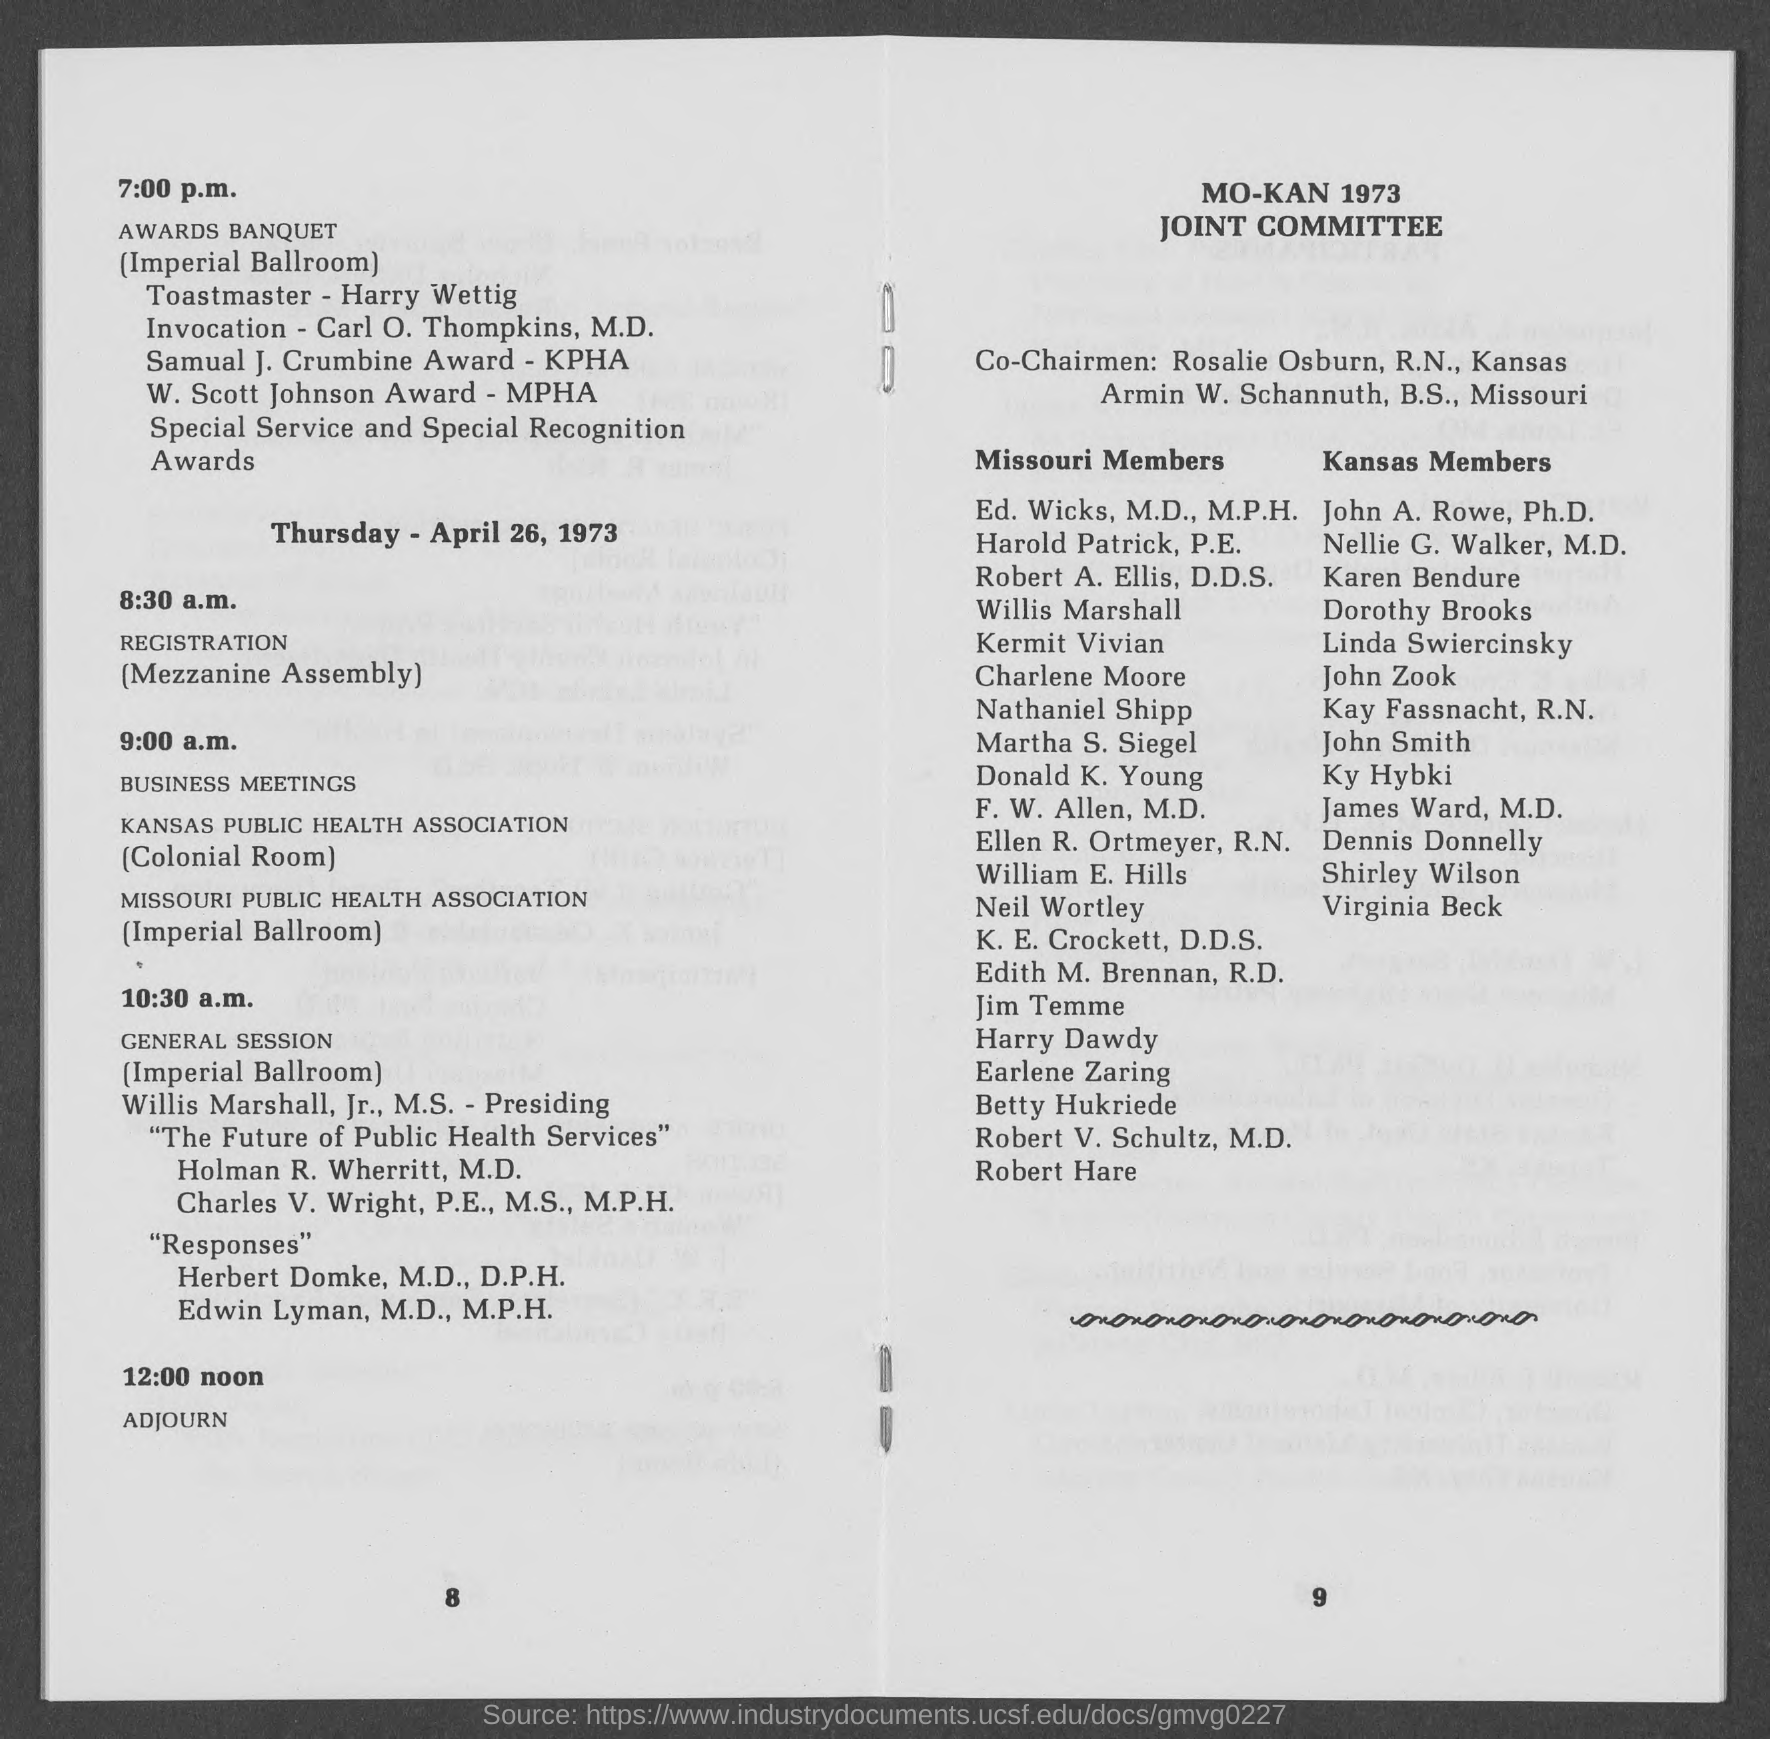Give some essential details in this illustration. The location of the Awards Banquet is the Imperial Ballroom. The business meetings of KANAS PUBLIC HEALTH ASSOCIATION are scheduled to begin at 9:00 a.m. The registration for the sessions will begin at 8:30 a.m. The Missouri Public Health Association holds its business meetings in the Imperial Ballroom. 